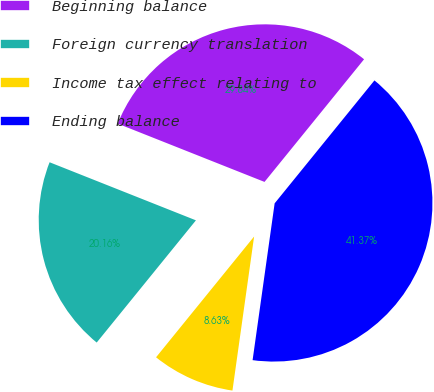Convert chart. <chart><loc_0><loc_0><loc_500><loc_500><pie_chart><fcel>Beginning balance<fcel>Foreign currency translation<fcel>Income tax effect relating to<fcel>Ending balance<nl><fcel>29.84%<fcel>20.16%<fcel>8.63%<fcel>41.37%<nl></chart> 